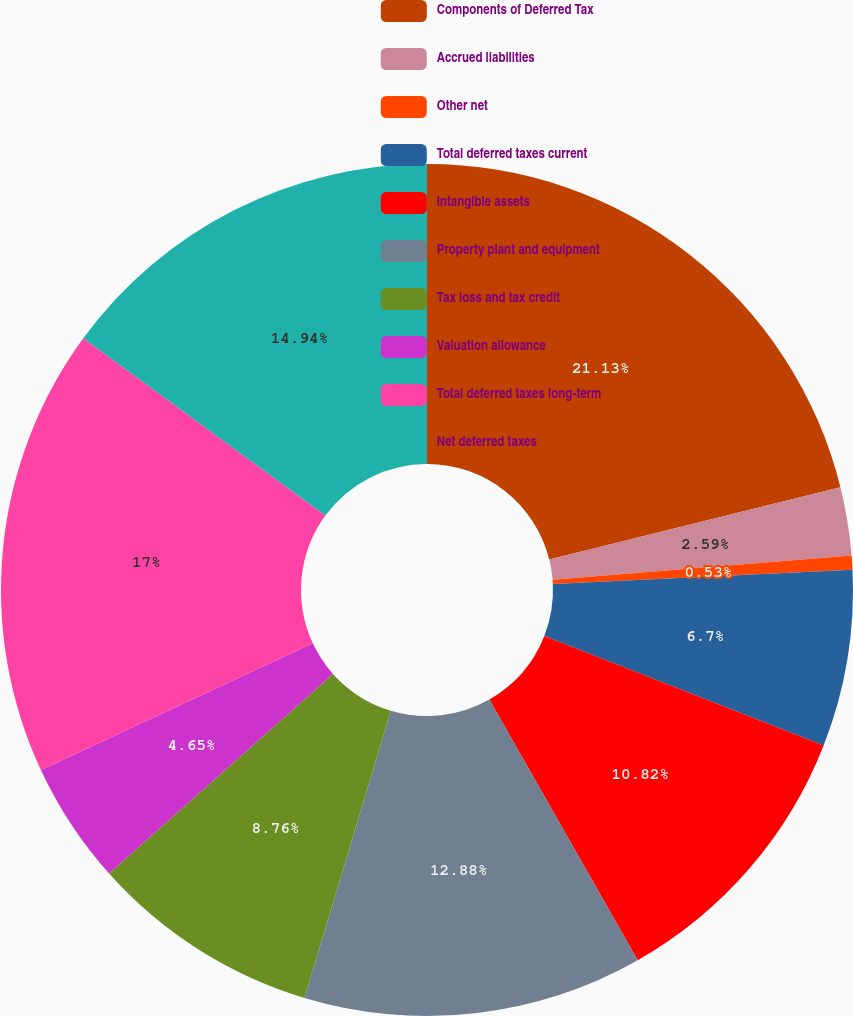<chart> <loc_0><loc_0><loc_500><loc_500><pie_chart><fcel>Components of Deferred Tax<fcel>Accrued liabilities<fcel>Other net<fcel>Total deferred taxes current<fcel>Intangible assets<fcel>Property plant and equipment<fcel>Tax loss and tax credit<fcel>Valuation allowance<fcel>Total deferred taxes long-term<fcel>Net deferred taxes<nl><fcel>21.12%<fcel>2.59%<fcel>0.53%<fcel>6.7%<fcel>10.82%<fcel>12.88%<fcel>8.76%<fcel>4.65%<fcel>17.0%<fcel>14.94%<nl></chart> 